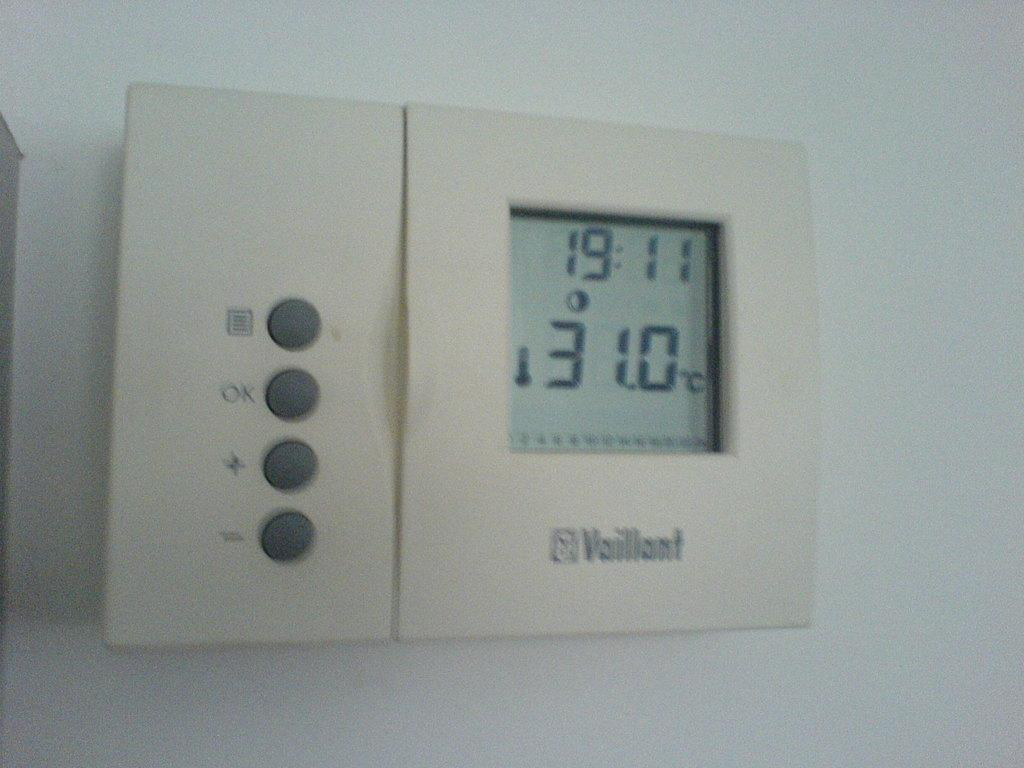<image>
Render a clear and concise summary of the photo. The thermostat reads a temperature of 31 degrees Celsius. 